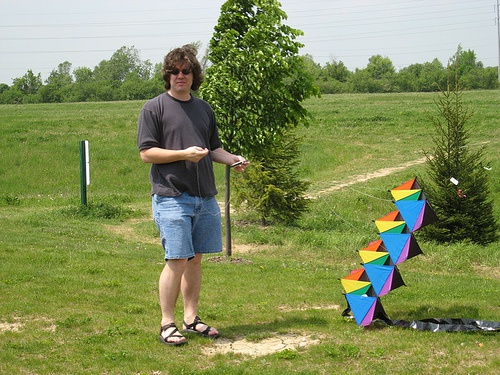Describe the objects in this image and their specific colors. I can see people in lightgray, black, and gray tones and kite in lightgray, lightblue, black, yellow, and gray tones in this image. 